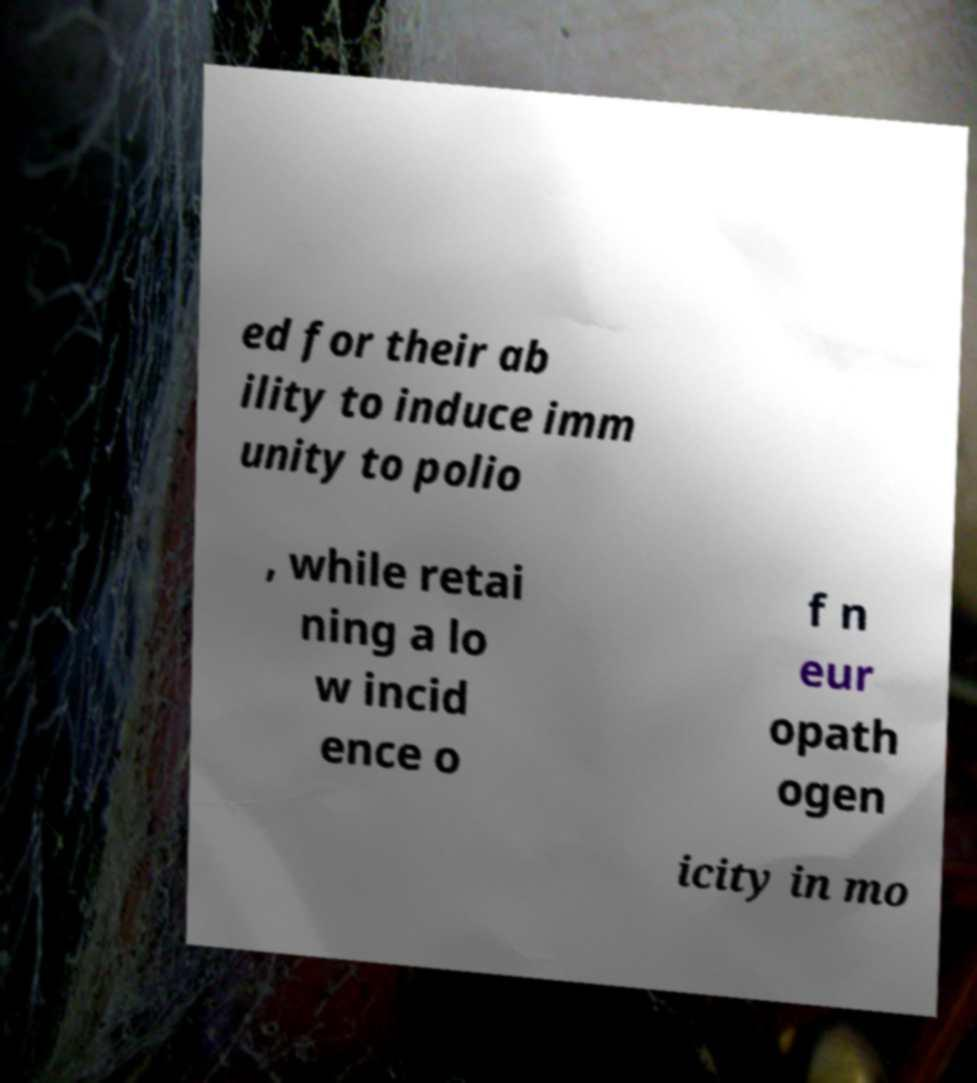Can you accurately transcribe the text from the provided image for me? ed for their ab ility to induce imm unity to polio , while retai ning a lo w incid ence o f n eur opath ogen icity in mo 